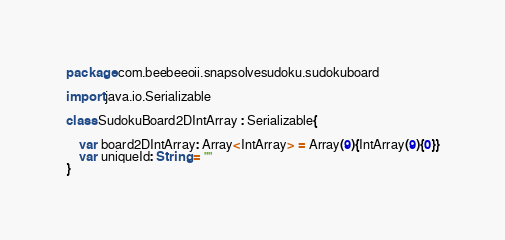<code> <loc_0><loc_0><loc_500><loc_500><_Kotlin_>package com.beebeeoii.snapsolvesudoku.sudokuboard

import java.io.Serializable

class SudokuBoard2DIntArray : Serializable{

    var board2DIntArray: Array<IntArray> = Array(9){IntArray(9){0}}
    var uniqueId: String = ""
}</code> 